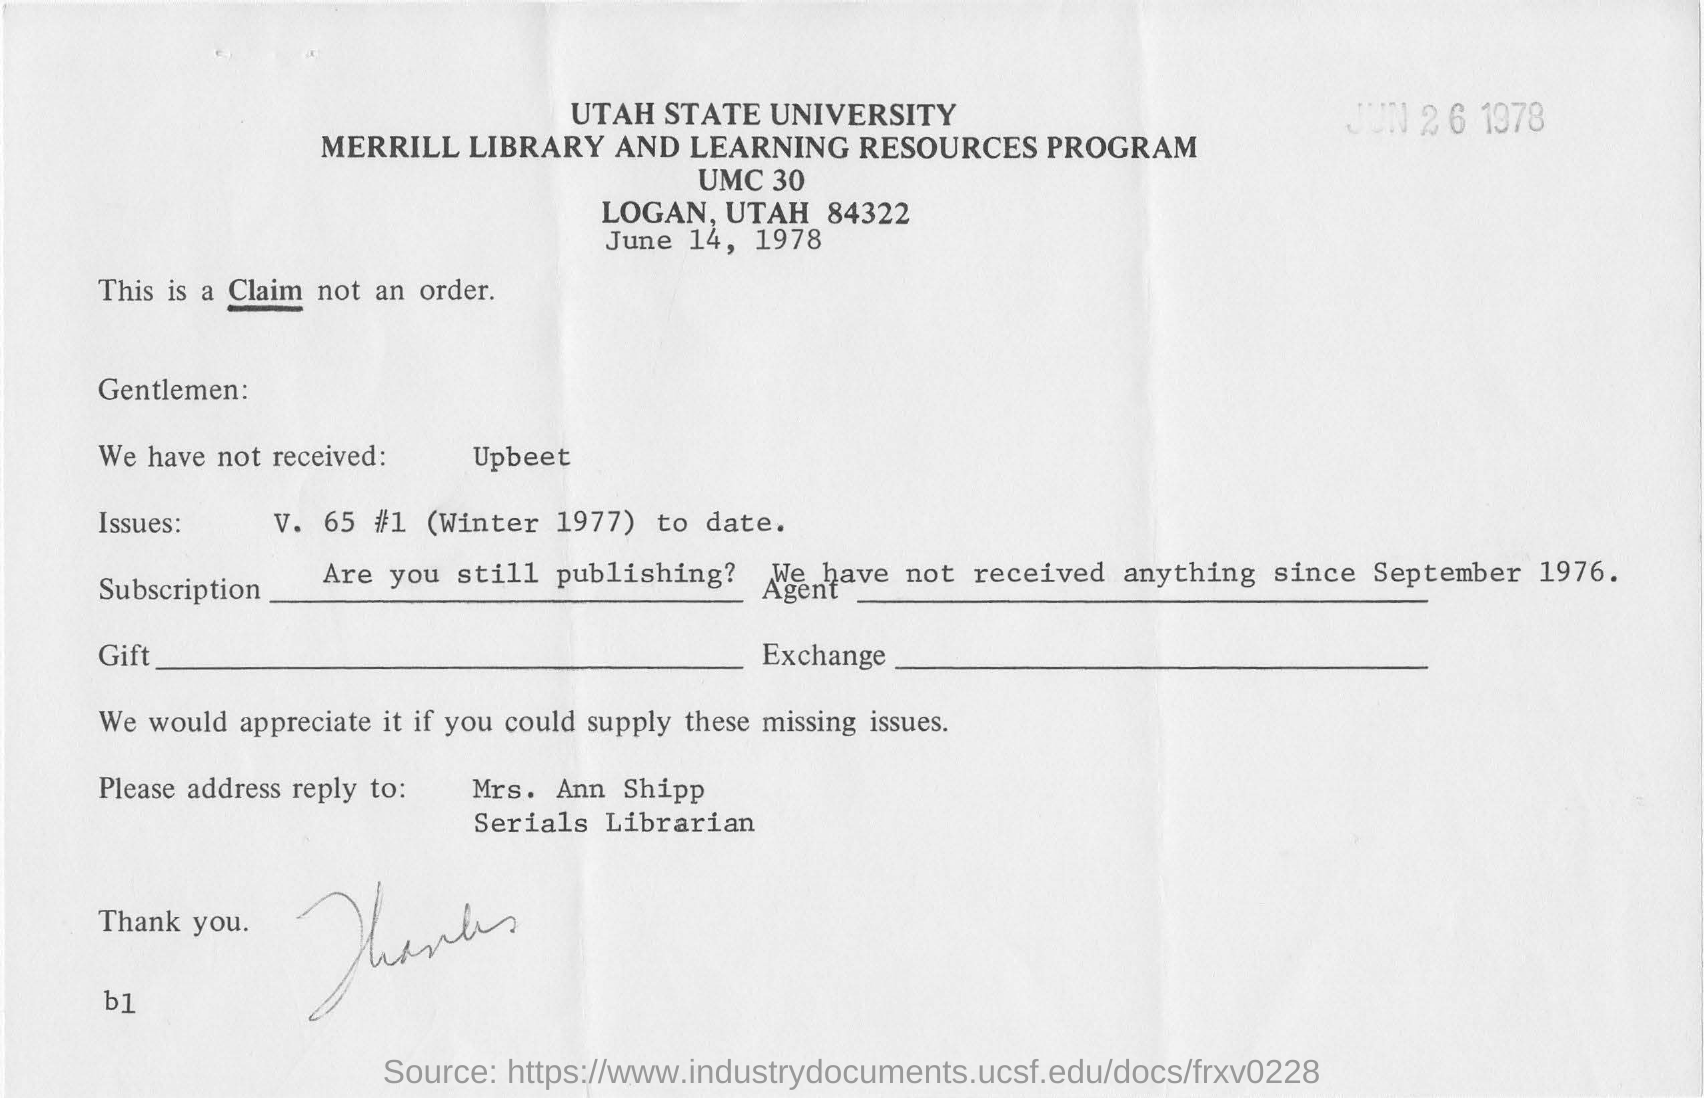Give some essential details in this illustration. Mrs. Ann Shipp is a serials librarian. The document mentions that the date is June 14, 1978. The document mentions Utah State University. The name of the librarian is Mrs. Ann Shipp. 